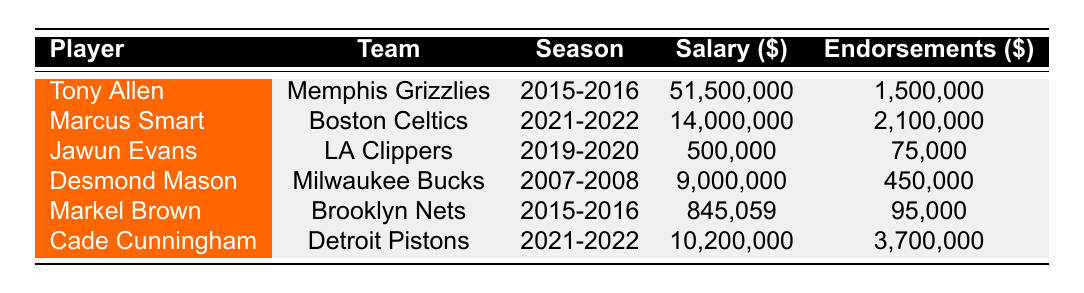What was Tony Allen's total earnings from salary and endorsements in the 2015-2016 season? Tony Allen's salary for the 2015-2016 season is 51,500,000 and his total endorsements amount to 1,500,000. Adding these two figures gives us 51,500,000 + 1,500,000 = 53,000,000.
Answer: 53,000,000 Which player had the highest endorsement earnings and what was the amount? Looking at the endorsements, Cade Cunningham had the highest contract value with 3,700,000. I checked all the players' endorsement earnings and confirmed that no other player's endorsements exceed this value.
Answer: 3,700,000 Did Desmond Mason earn more from salary or endorsements in the 2007-2008 season? Desmond Mason's salary was 9,000,000 and his endorsements were 450,000. Since 9,000,000 is greater than 450,000, he earned more from salary than endorsements.
Answer: Yes What is the total salary of all players listed in the table? To find the total salary, I added each player's salary: 51,500,000 + 14,000,000 + 500,000 + 9,000,000 + 845,059 + 10,200,000 = 85,045,059.
Answer: 85,045,059 How many players had endorsement contracts with Nike? By checking the endorsements, I found that Tony Allen, Marcus Smart, Markel Brown, and Cade Cunningham all had contracts with Nike, totaling 4 players.
Answer: 4 